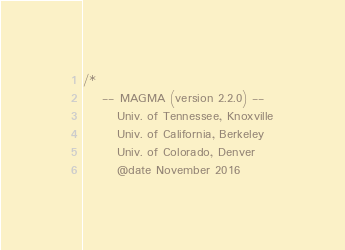<code> <loc_0><loc_0><loc_500><loc_500><_Cuda_>/*
    -- MAGMA (version 2.2.0) --
       Univ. of Tennessee, Knoxville
       Univ. of California, Berkeley
       Univ. of Colorado, Denver
       @date November 2016
</code> 